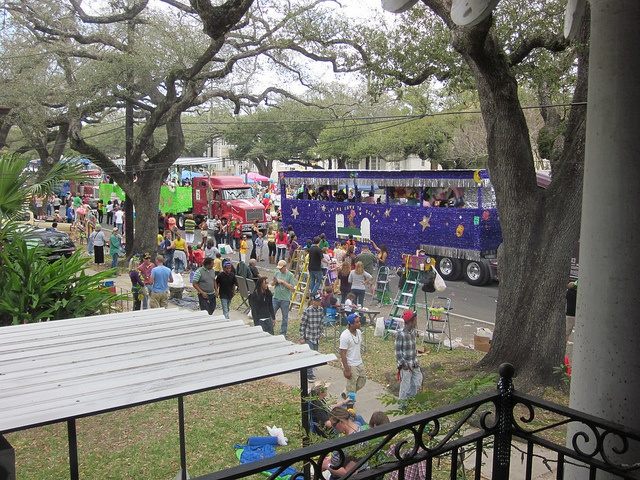Describe the objects in this image and their specific colors. I can see bus in white, navy, gray, black, and purple tones, people in white, gray, darkgray, and black tones, truck in white, gray, darkgray, lightgray, and lightpink tones, people in white, gray, and darkgray tones, and people in white, gray, darkgray, and black tones in this image. 